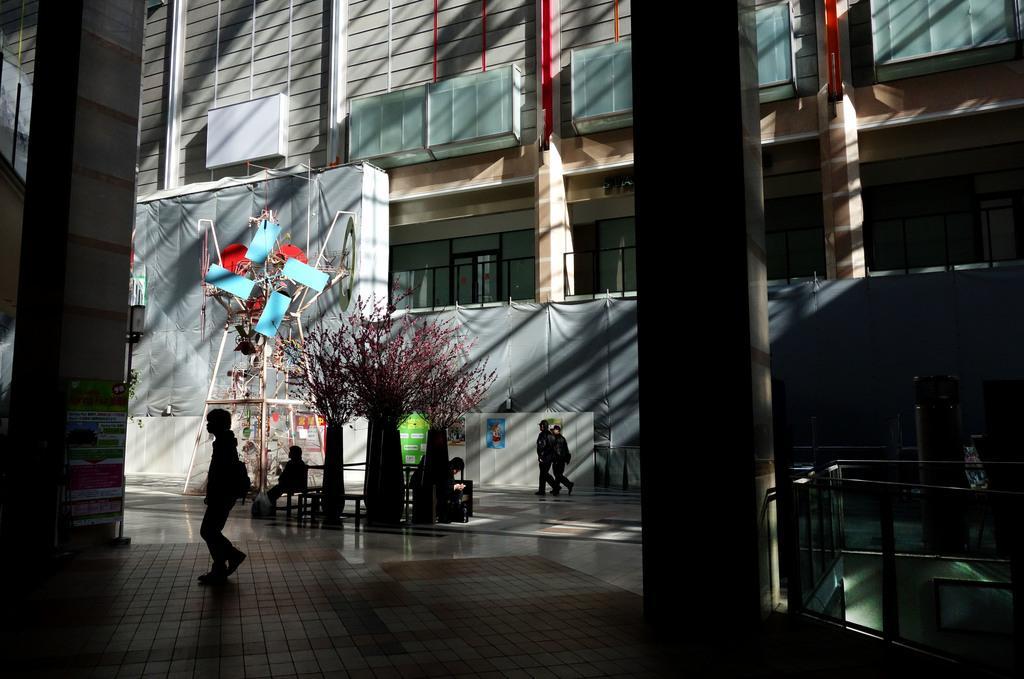How would you summarize this image in a sentence or two? This picture is clicked outside. In the foreground we can see the pillars, deck rails and group of persons and we can see a banner on which we can see the text and some pictures. In the center we can see the plants, chairs, wooden objects and some items. In the background we can see the buildings and we can see the windows of the buildings and we can see the window blinds and curtains and some other objects. 